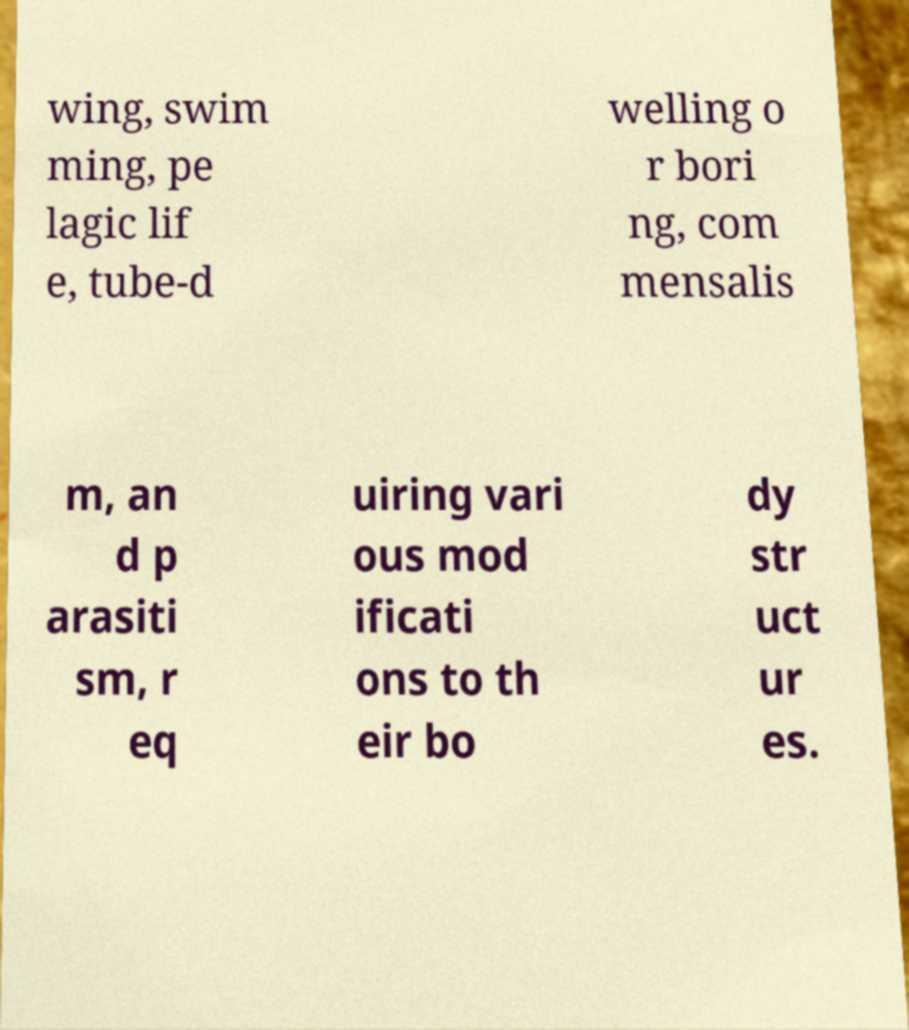I need the written content from this picture converted into text. Can you do that? wing, swim ming, pe lagic lif e, tube-d welling o r bori ng, com mensalis m, an d p arasiti sm, r eq uiring vari ous mod ificati ons to th eir bo dy str uct ur es. 